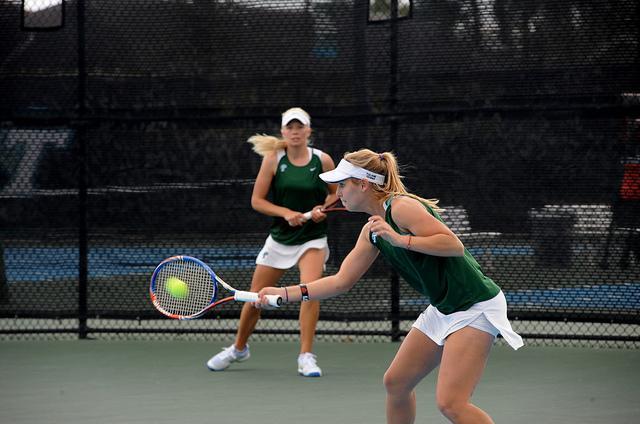How many people are in the photo?
Give a very brief answer. 2. 